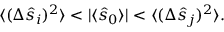<formula> <loc_0><loc_0><loc_500><loc_500>\begin{array} { r } { \langle ( \Delta \hat { s } _ { i } ) ^ { 2 } \rangle < | \langle \hat { s } _ { 0 } \rangle | < \langle ( \Delta \hat { s } _ { j } ) ^ { 2 } \rangle . } \end{array}</formula> 